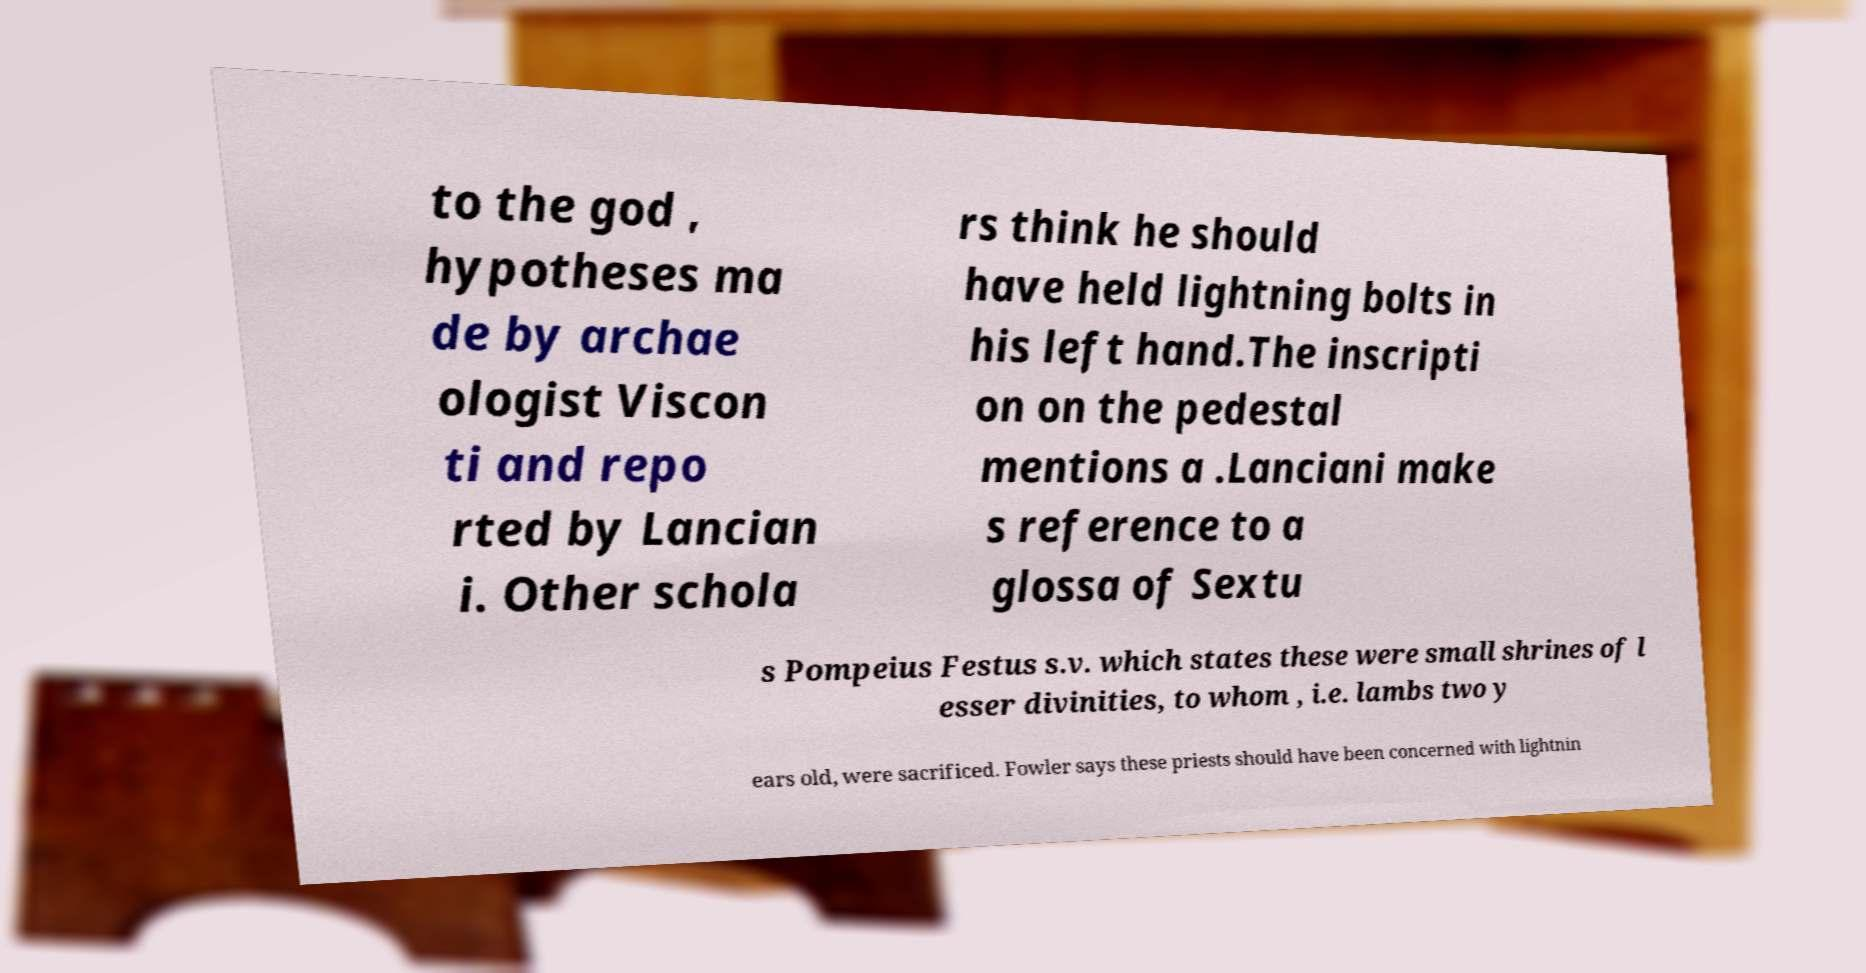Could you extract and type out the text from this image? to the god , hypotheses ma de by archae ologist Viscon ti and repo rted by Lancian i. Other schola rs think he should have held lightning bolts in his left hand.The inscripti on on the pedestal mentions a .Lanciani make s reference to a glossa of Sextu s Pompeius Festus s.v. which states these were small shrines of l esser divinities, to whom , i.e. lambs two y ears old, were sacrificed. Fowler says these priests should have been concerned with lightnin 